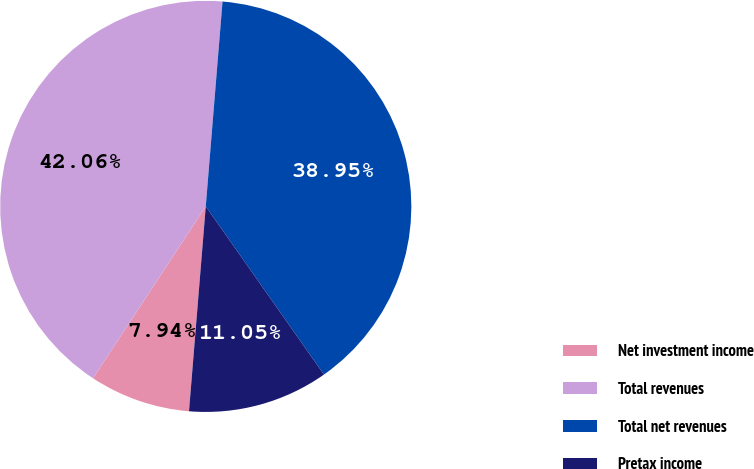Convert chart to OTSL. <chart><loc_0><loc_0><loc_500><loc_500><pie_chart><fcel>Net investment income<fcel>Total revenues<fcel>Total net revenues<fcel>Pretax income<nl><fcel>7.94%<fcel>42.06%<fcel>38.95%<fcel>11.05%<nl></chart> 